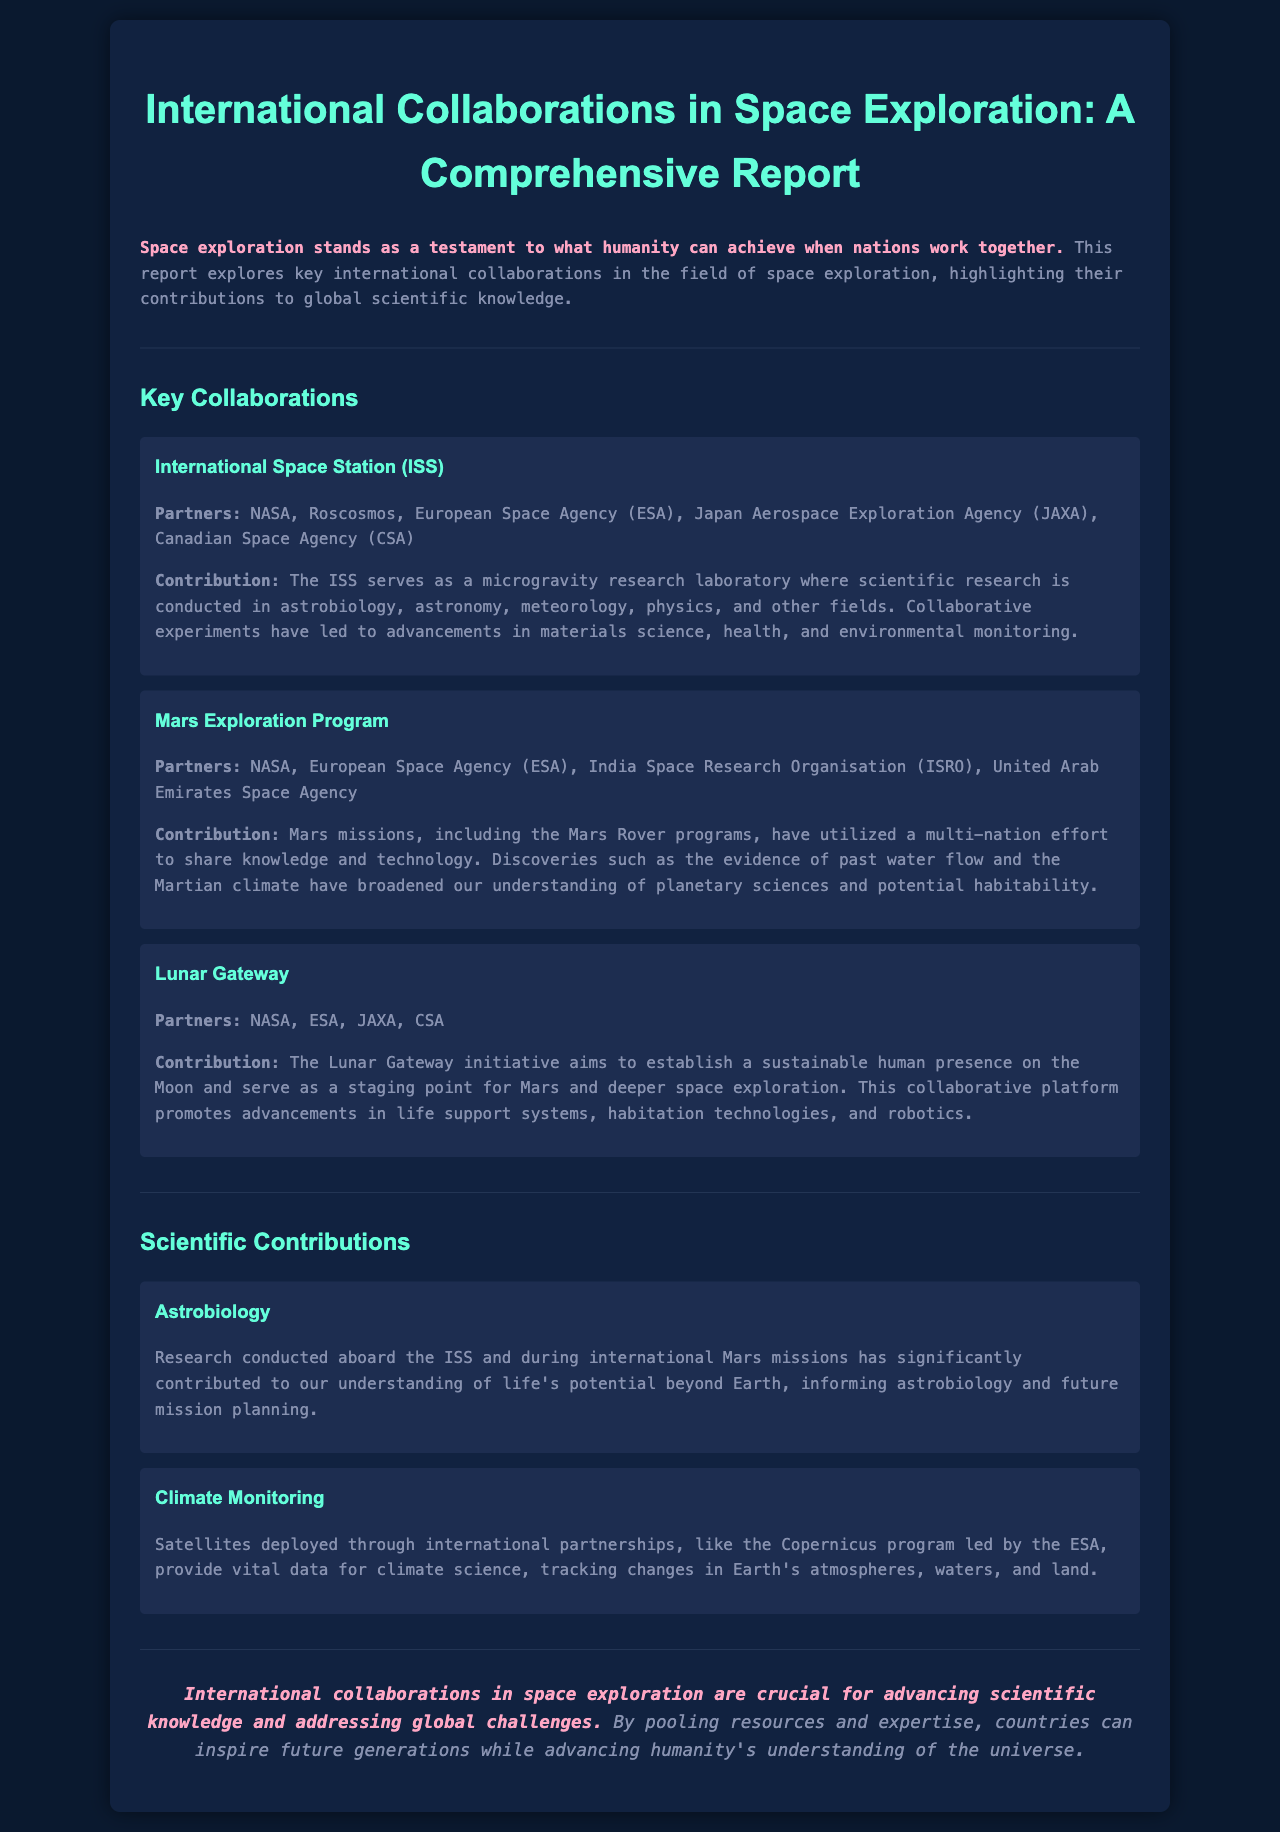What is the title of the report? The title of the report is the main heading found at the top of the document.
Answer: International Collaborations in Space Exploration: A Comprehensive Report Who are the partners of the International Space Station (ISS)? The document lists the partners involved in the ISS collaboration under the respective section.
Answer: NASA, Roscosmos, European Space Agency, Japan Aerospace Exploration Agency, Canadian Space Agency What field of research has benefited from the ISS? The contributions of the ISS include advancements in various fields of scientific research mentioned in the report.
Answer: Astrobiology, astronomy, meteorology, physics Name one key focus of the Mars Exploration Program. The document mentions specific discoveries made through the Mars missions that can be identified as key focuses under this collaborative effort.
Answer: Evidence of past water flow What is the aim of the Lunar Gateway initiative? The report outlines the objectives of the Lunar Gateway which gives insight into its purpose.
Answer: Establish a sustainable human presence on the Moon Which program is associated with climate monitoring? The report refers to a specific international program responsible for providing climate data.
Answer: Copernicus program How do international collaborations in space exploration impact future generations? The conclusion of the report highlights the overall significance of these collaborations.
Answer: Inspire future generations What is a major contribution of astrobiology research from the collaborations? The document focuses on the impact of research on understanding potential life beyond Earth as a significant contribution.
Answer: Understanding of life’s potential beyond Earth 